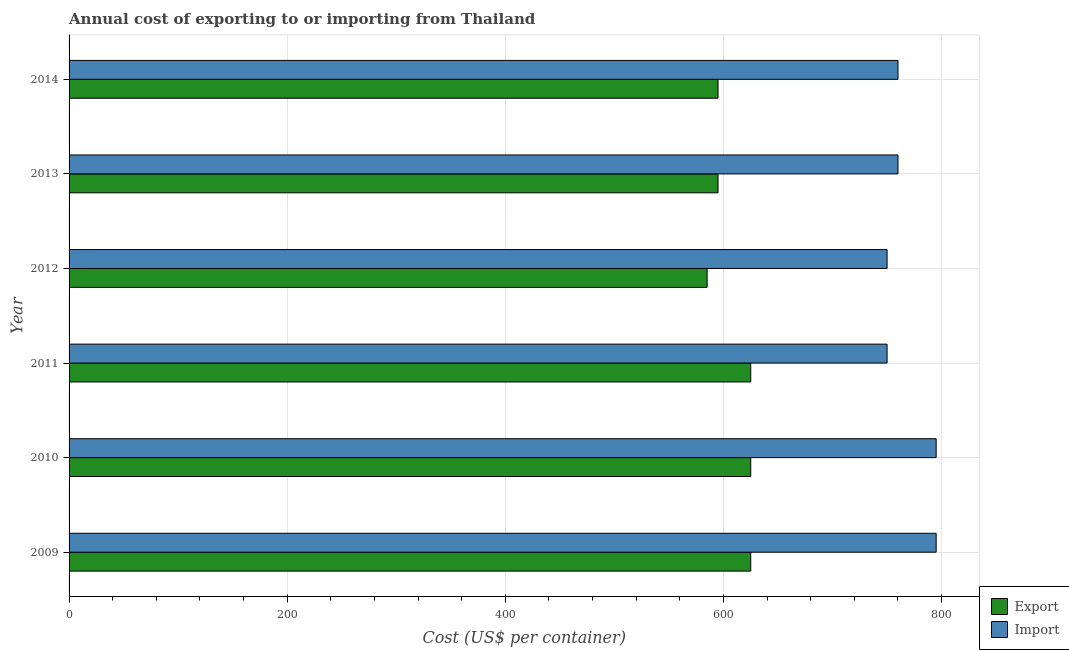How many groups of bars are there?
Ensure brevity in your answer.  6. What is the label of the 3rd group of bars from the top?
Offer a very short reply. 2012. What is the import cost in 2011?
Give a very brief answer. 750. Across all years, what is the maximum import cost?
Offer a terse response. 795. Across all years, what is the minimum export cost?
Give a very brief answer. 585. In which year was the export cost maximum?
Your answer should be compact. 2009. In which year was the import cost minimum?
Provide a short and direct response. 2011. What is the total import cost in the graph?
Provide a short and direct response. 4610. What is the difference between the import cost in 2009 and that in 2014?
Keep it short and to the point. 35. What is the difference between the export cost in 2012 and the import cost in 2009?
Provide a succinct answer. -210. What is the average export cost per year?
Offer a terse response. 608.33. In the year 2013, what is the difference between the export cost and import cost?
Provide a short and direct response. -165. In how many years, is the export cost greater than 120 US$?
Make the answer very short. 6. What is the ratio of the import cost in 2011 to that in 2013?
Give a very brief answer. 0.99. Is the difference between the import cost in 2012 and 2014 greater than the difference between the export cost in 2012 and 2014?
Offer a very short reply. No. What is the difference between the highest and the lowest export cost?
Your response must be concise. 40. In how many years, is the import cost greater than the average import cost taken over all years?
Provide a short and direct response. 2. Is the sum of the export cost in 2012 and 2014 greater than the maximum import cost across all years?
Ensure brevity in your answer.  Yes. What does the 1st bar from the top in 2009 represents?
Make the answer very short. Import. What does the 2nd bar from the bottom in 2010 represents?
Provide a succinct answer. Import. Are all the bars in the graph horizontal?
Make the answer very short. Yes. How many years are there in the graph?
Your answer should be very brief. 6. Does the graph contain any zero values?
Give a very brief answer. No. What is the title of the graph?
Provide a succinct answer. Annual cost of exporting to or importing from Thailand. Does "Automatic Teller Machines" appear as one of the legend labels in the graph?
Offer a terse response. No. What is the label or title of the X-axis?
Give a very brief answer. Cost (US$ per container). What is the label or title of the Y-axis?
Offer a very short reply. Year. What is the Cost (US$ per container) of Export in 2009?
Ensure brevity in your answer.  625. What is the Cost (US$ per container) in Import in 2009?
Keep it short and to the point. 795. What is the Cost (US$ per container) of Export in 2010?
Ensure brevity in your answer.  625. What is the Cost (US$ per container) of Import in 2010?
Your answer should be compact. 795. What is the Cost (US$ per container) in Export in 2011?
Your response must be concise. 625. What is the Cost (US$ per container) in Import in 2011?
Provide a succinct answer. 750. What is the Cost (US$ per container) in Export in 2012?
Provide a succinct answer. 585. What is the Cost (US$ per container) of Import in 2012?
Provide a succinct answer. 750. What is the Cost (US$ per container) of Export in 2013?
Provide a succinct answer. 595. What is the Cost (US$ per container) of Import in 2013?
Ensure brevity in your answer.  760. What is the Cost (US$ per container) of Export in 2014?
Make the answer very short. 595. What is the Cost (US$ per container) of Import in 2014?
Provide a succinct answer. 760. Across all years, what is the maximum Cost (US$ per container) of Export?
Offer a very short reply. 625. Across all years, what is the maximum Cost (US$ per container) of Import?
Offer a terse response. 795. Across all years, what is the minimum Cost (US$ per container) in Export?
Keep it short and to the point. 585. Across all years, what is the minimum Cost (US$ per container) in Import?
Offer a terse response. 750. What is the total Cost (US$ per container) in Export in the graph?
Give a very brief answer. 3650. What is the total Cost (US$ per container) in Import in the graph?
Offer a very short reply. 4610. What is the difference between the Cost (US$ per container) in Export in 2009 and that in 2010?
Provide a short and direct response. 0. What is the difference between the Cost (US$ per container) in Export in 2009 and that in 2011?
Your response must be concise. 0. What is the difference between the Cost (US$ per container) of Import in 2009 and that in 2011?
Your answer should be compact. 45. What is the difference between the Cost (US$ per container) of Export in 2009 and that in 2012?
Provide a succinct answer. 40. What is the difference between the Cost (US$ per container) of Export in 2009 and that in 2013?
Your response must be concise. 30. What is the difference between the Cost (US$ per container) in Import in 2009 and that in 2013?
Provide a succinct answer. 35. What is the difference between the Cost (US$ per container) of Export in 2009 and that in 2014?
Ensure brevity in your answer.  30. What is the difference between the Cost (US$ per container) of Import in 2009 and that in 2014?
Your response must be concise. 35. What is the difference between the Cost (US$ per container) of Import in 2010 and that in 2011?
Make the answer very short. 45. What is the difference between the Cost (US$ per container) of Import in 2010 and that in 2012?
Ensure brevity in your answer.  45. What is the difference between the Cost (US$ per container) in Export in 2010 and that in 2014?
Your answer should be very brief. 30. What is the difference between the Cost (US$ per container) in Export in 2011 and that in 2012?
Your answer should be compact. 40. What is the difference between the Cost (US$ per container) in Import in 2011 and that in 2012?
Offer a very short reply. 0. What is the difference between the Cost (US$ per container) in Export in 2011 and that in 2013?
Make the answer very short. 30. What is the difference between the Cost (US$ per container) in Import in 2011 and that in 2014?
Your answer should be very brief. -10. What is the difference between the Cost (US$ per container) in Import in 2012 and that in 2013?
Provide a short and direct response. -10. What is the difference between the Cost (US$ per container) in Export in 2012 and that in 2014?
Provide a succinct answer. -10. What is the difference between the Cost (US$ per container) in Export in 2013 and that in 2014?
Your response must be concise. 0. What is the difference between the Cost (US$ per container) in Import in 2013 and that in 2014?
Offer a terse response. 0. What is the difference between the Cost (US$ per container) in Export in 2009 and the Cost (US$ per container) in Import in 2010?
Your answer should be very brief. -170. What is the difference between the Cost (US$ per container) in Export in 2009 and the Cost (US$ per container) in Import in 2011?
Your answer should be very brief. -125. What is the difference between the Cost (US$ per container) of Export in 2009 and the Cost (US$ per container) of Import in 2012?
Give a very brief answer. -125. What is the difference between the Cost (US$ per container) in Export in 2009 and the Cost (US$ per container) in Import in 2013?
Provide a short and direct response. -135. What is the difference between the Cost (US$ per container) of Export in 2009 and the Cost (US$ per container) of Import in 2014?
Offer a terse response. -135. What is the difference between the Cost (US$ per container) in Export in 2010 and the Cost (US$ per container) in Import in 2011?
Your answer should be compact. -125. What is the difference between the Cost (US$ per container) of Export in 2010 and the Cost (US$ per container) of Import in 2012?
Your response must be concise. -125. What is the difference between the Cost (US$ per container) of Export in 2010 and the Cost (US$ per container) of Import in 2013?
Provide a succinct answer. -135. What is the difference between the Cost (US$ per container) of Export in 2010 and the Cost (US$ per container) of Import in 2014?
Keep it short and to the point. -135. What is the difference between the Cost (US$ per container) of Export in 2011 and the Cost (US$ per container) of Import in 2012?
Offer a terse response. -125. What is the difference between the Cost (US$ per container) of Export in 2011 and the Cost (US$ per container) of Import in 2013?
Keep it short and to the point. -135. What is the difference between the Cost (US$ per container) of Export in 2011 and the Cost (US$ per container) of Import in 2014?
Provide a short and direct response. -135. What is the difference between the Cost (US$ per container) of Export in 2012 and the Cost (US$ per container) of Import in 2013?
Your answer should be very brief. -175. What is the difference between the Cost (US$ per container) of Export in 2012 and the Cost (US$ per container) of Import in 2014?
Your answer should be very brief. -175. What is the difference between the Cost (US$ per container) of Export in 2013 and the Cost (US$ per container) of Import in 2014?
Provide a short and direct response. -165. What is the average Cost (US$ per container) of Export per year?
Provide a succinct answer. 608.33. What is the average Cost (US$ per container) in Import per year?
Keep it short and to the point. 768.33. In the year 2009, what is the difference between the Cost (US$ per container) of Export and Cost (US$ per container) of Import?
Make the answer very short. -170. In the year 2010, what is the difference between the Cost (US$ per container) of Export and Cost (US$ per container) of Import?
Offer a very short reply. -170. In the year 2011, what is the difference between the Cost (US$ per container) in Export and Cost (US$ per container) in Import?
Your answer should be very brief. -125. In the year 2012, what is the difference between the Cost (US$ per container) of Export and Cost (US$ per container) of Import?
Offer a terse response. -165. In the year 2013, what is the difference between the Cost (US$ per container) in Export and Cost (US$ per container) in Import?
Offer a terse response. -165. In the year 2014, what is the difference between the Cost (US$ per container) of Export and Cost (US$ per container) of Import?
Keep it short and to the point. -165. What is the ratio of the Cost (US$ per container) of Import in 2009 to that in 2010?
Offer a terse response. 1. What is the ratio of the Cost (US$ per container) in Import in 2009 to that in 2011?
Make the answer very short. 1.06. What is the ratio of the Cost (US$ per container) in Export in 2009 to that in 2012?
Ensure brevity in your answer.  1.07. What is the ratio of the Cost (US$ per container) of Import in 2009 to that in 2012?
Keep it short and to the point. 1.06. What is the ratio of the Cost (US$ per container) of Export in 2009 to that in 2013?
Your response must be concise. 1.05. What is the ratio of the Cost (US$ per container) of Import in 2009 to that in 2013?
Your answer should be compact. 1.05. What is the ratio of the Cost (US$ per container) in Export in 2009 to that in 2014?
Offer a very short reply. 1.05. What is the ratio of the Cost (US$ per container) in Import in 2009 to that in 2014?
Keep it short and to the point. 1.05. What is the ratio of the Cost (US$ per container) in Import in 2010 to that in 2011?
Keep it short and to the point. 1.06. What is the ratio of the Cost (US$ per container) of Export in 2010 to that in 2012?
Your answer should be compact. 1.07. What is the ratio of the Cost (US$ per container) in Import in 2010 to that in 2012?
Offer a terse response. 1.06. What is the ratio of the Cost (US$ per container) of Export in 2010 to that in 2013?
Provide a short and direct response. 1.05. What is the ratio of the Cost (US$ per container) in Import in 2010 to that in 2013?
Offer a very short reply. 1.05. What is the ratio of the Cost (US$ per container) in Export in 2010 to that in 2014?
Your answer should be very brief. 1.05. What is the ratio of the Cost (US$ per container) of Import in 2010 to that in 2014?
Provide a short and direct response. 1.05. What is the ratio of the Cost (US$ per container) in Export in 2011 to that in 2012?
Offer a very short reply. 1.07. What is the ratio of the Cost (US$ per container) in Import in 2011 to that in 2012?
Offer a terse response. 1. What is the ratio of the Cost (US$ per container) of Export in 2011 to that in 2013?
Give a very brief answer. 1.05. What is the ratio of the Cost (US$ per container) of Import in 2011 to that in 2013?
Offer a terse response. 0.99. What is the ratio of the Cost (US$ per container) in Export in 2011 to that in 2014?
Your answer should be very brief. 1.05. What is the ratio of the Cost (US$ per container) of Export in 2012 to that in 2013?
Ensure brevity in your answer.  0.98. What is the ratio of the Cost (US$ per container) in Import in 2012 to that in 2013?
Offer a very short reply. 0.99. What is the ratio of the Cost (US$ per container) in Export in 2012 to that in 2014?
Your response must be concise. 0.98. What is the ratio of the Cost (US$ per container) of Import in 2012 to that in 2014?
Provide a succinct answer. 0.99. What is the ratio of the Cost (US$ per container) in Export in 2013 to that in 2014?
Your response must be concise. 1. What is the difference between the highest and the lowest Cost (US$ per container) in Import?
Keep it short and to the point. 45. 